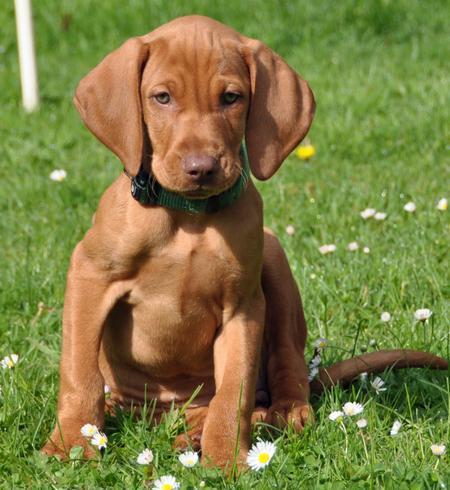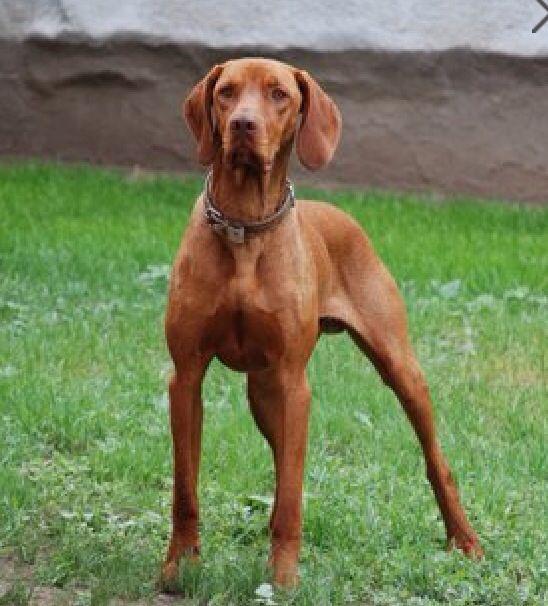The first image is the image on the left, the second image is the image on the right. Examine the images to the left and right. Is the description "There are only two dogs." accurate? Answer yes or no. Yes. The first image is the image on the left, the second image is the image on the right. For the images displayed, is the sentence "One image shows a dog running toward the camera, and the other image shows a dog in a still position gazing rightward." factually correct? Answer yes or no. No. 